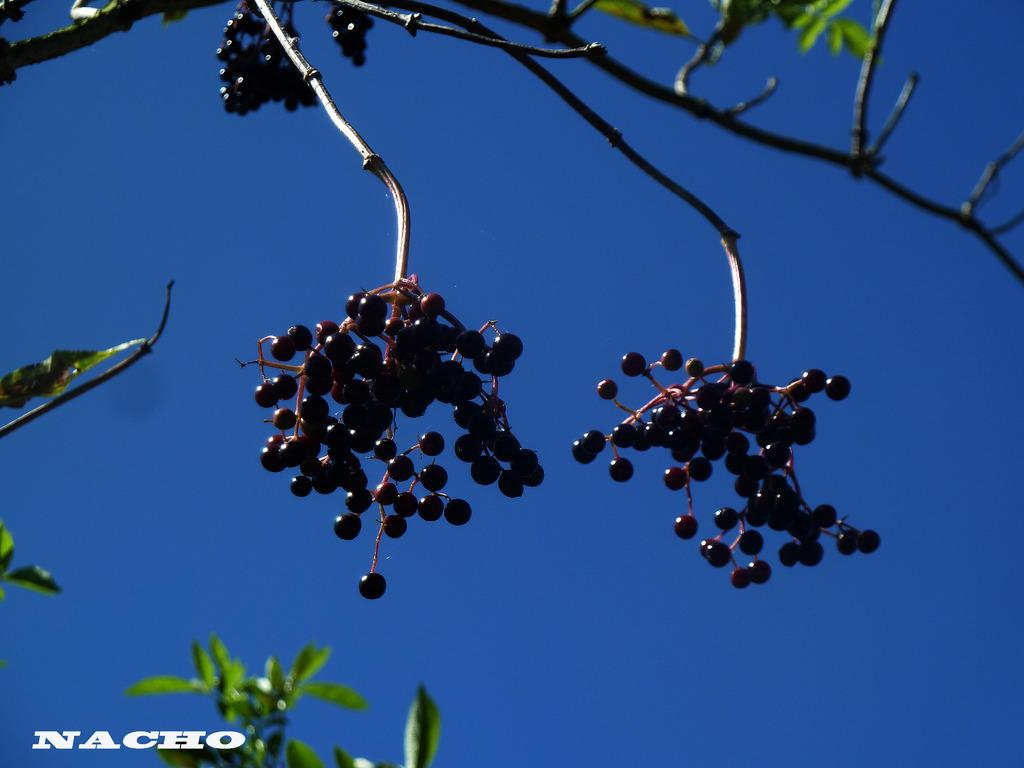What type of fruit can be seen hanging from the tree in the image? Elderberries are hanging from a tree in the image. What can be seen in the background of the image? The sky is visible in the background of the image. Is there any additional information or marking on the image? Yes, there is a watermark on the image. What type of ticket is visible in the image? There is no ticket present in the image. How does the toothpaste relate to the elderberries in the image? There is no toothpaste present in the image, so it does not relate to the elderberries. 